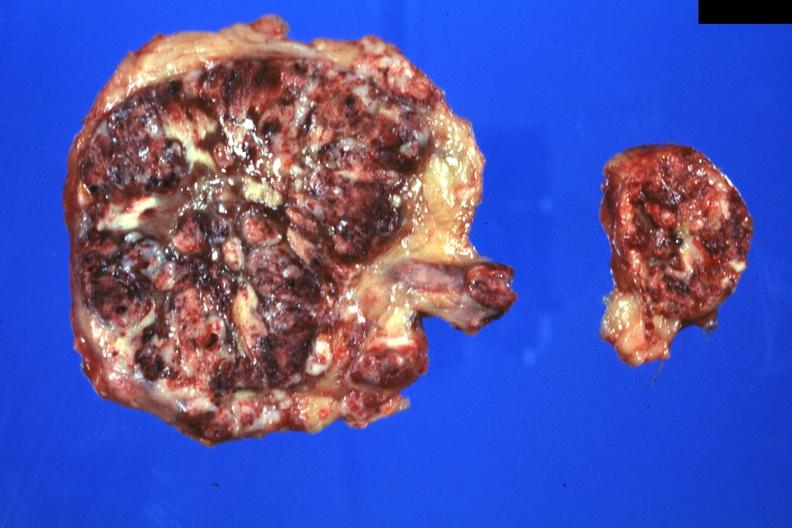s endocrine present?
Answer the question using a single word or phrase. Yes 